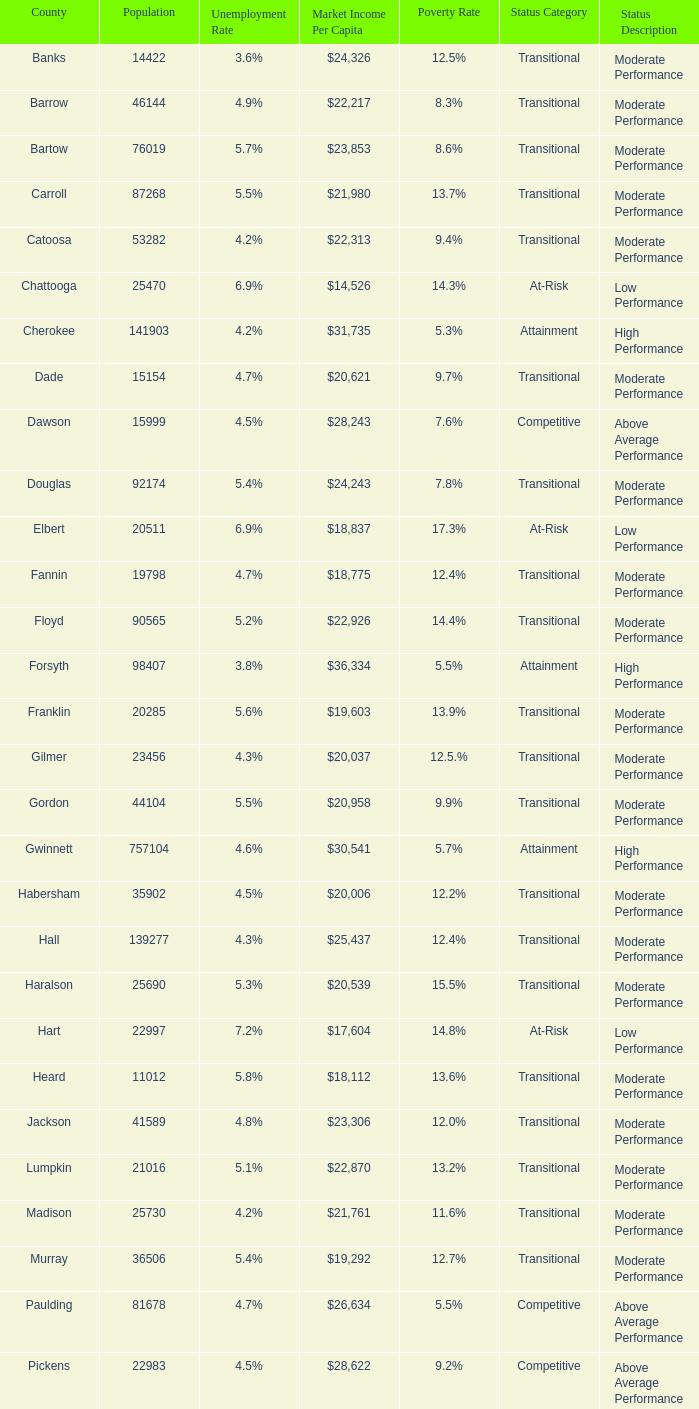Which county had a 3.6% unemployment rate? Banks. 